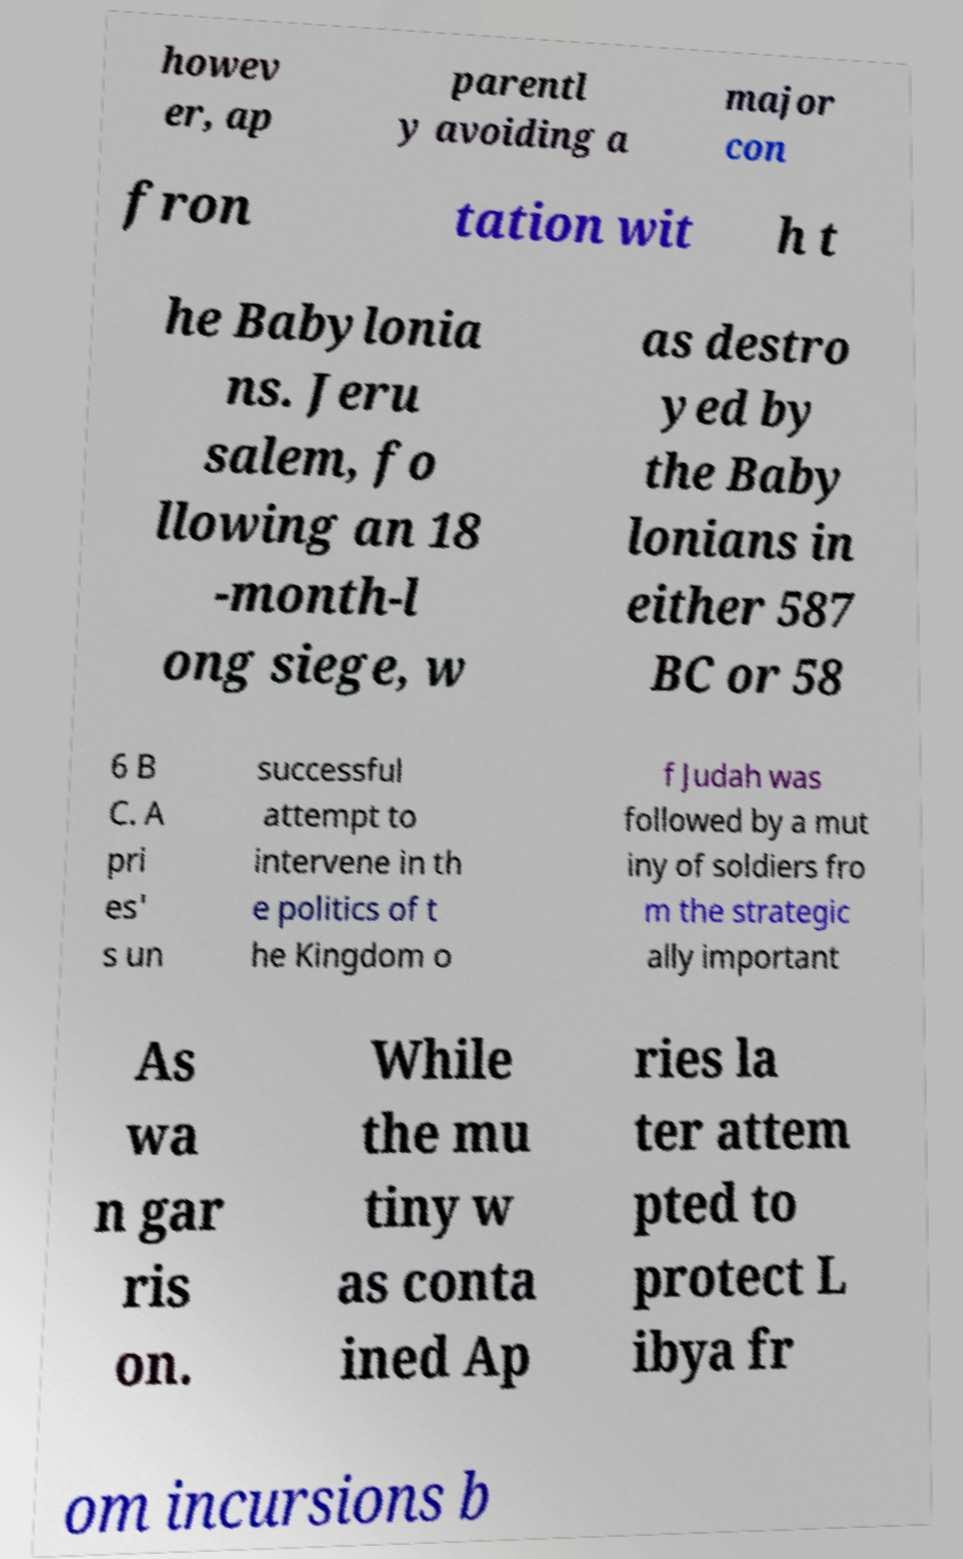Could you extract and type out the text from this image? howev er, ap parentl y avoiding a major con fron tation wit h t he Babylonia ns. Jeru salem, fo llowing an 18 -month-l ong siege, w as destro yed by the Baby lonians in either 587 BC or 58 6 B C. A pri es' s un successful attempt to intervene in th e politics of t he Kingdom o f Judah was followed by a mut iny of soldiers fro m the strategic ally important As wa n gar ris on. While the mu tiny w as conta ined Ap ries la ter attem pted to protect L ibya fr om incursions b 